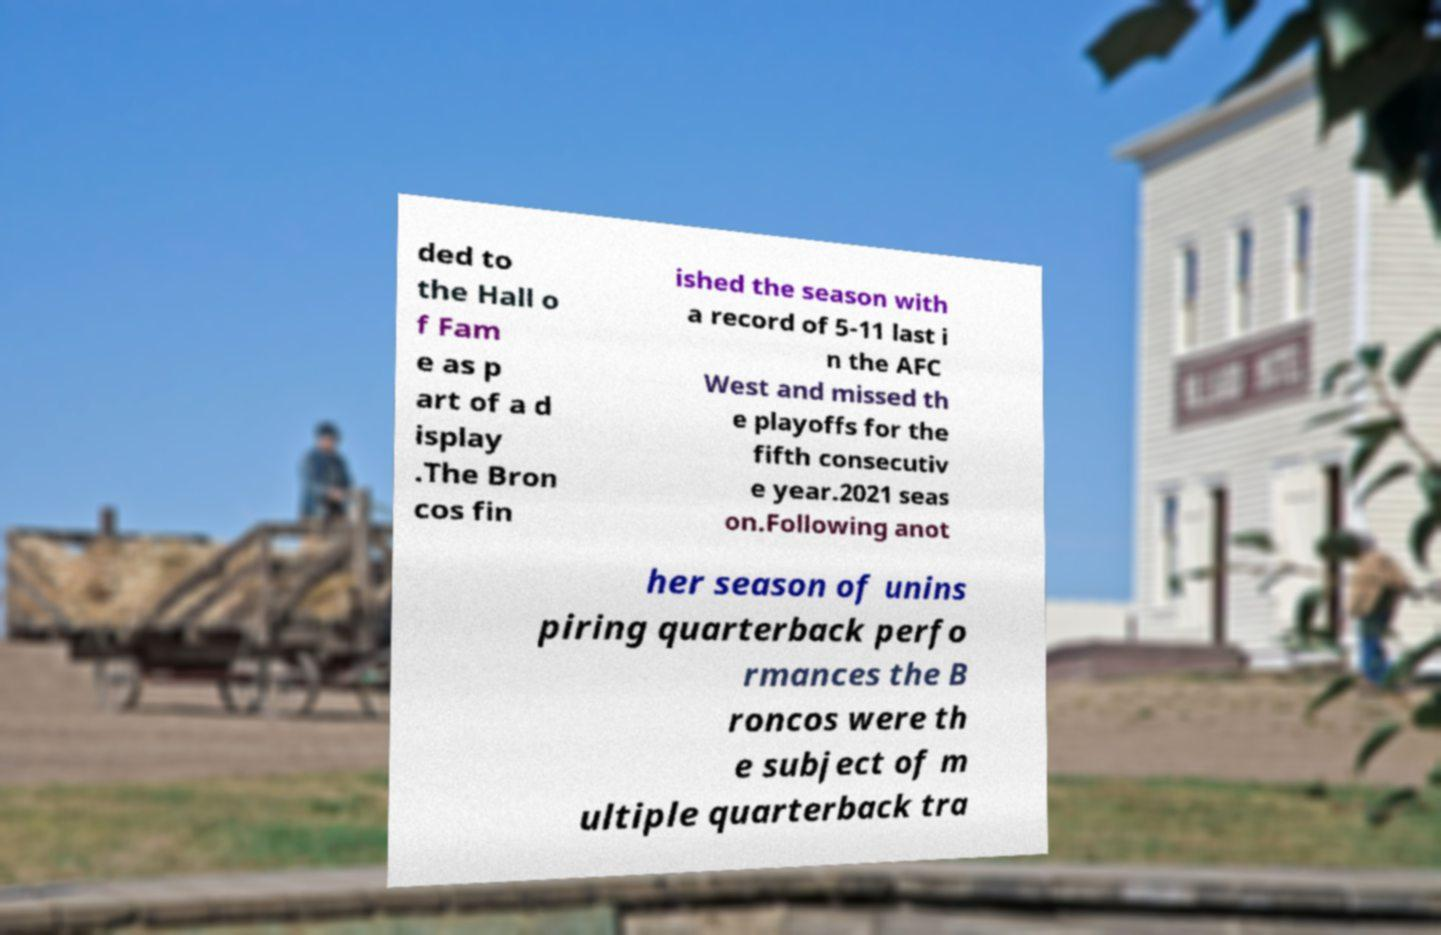Could you assist in decoding the text presented in this image and type it out clearly? ded to the Hall o f Fam e as p art of a d isplay .The Bron cos fin ished the season with a record of 5-11 last i n the AFC West and missed th e playoffs for the fifth consecutiv e year.2021 seas on.Following anot her season of unins piring quarterback perfo rmances the B roncos were th e subject of m ultiple quarterback tra 